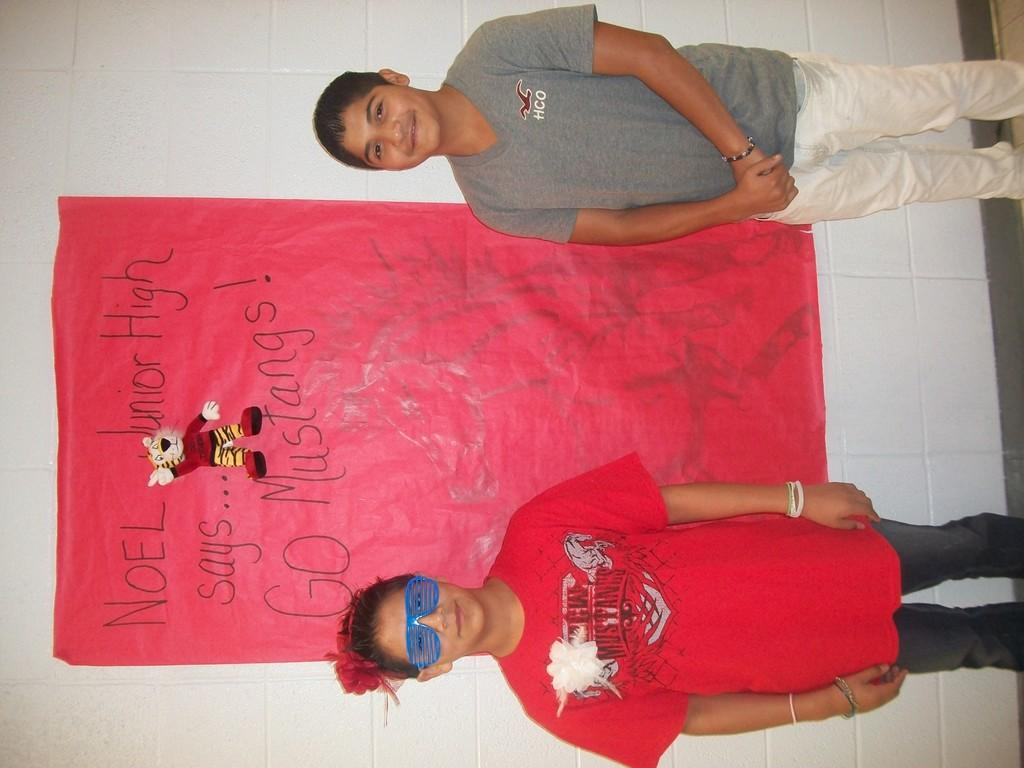How many children are present in the image? There are two children standing in the image. Where are the children standing? The children are standing on the floor. What can be seen on the wall in the background of the image? There is a paper on the wall, which has a picture and some text on it. What type of bean is being used as a prop in the image? There is no bean present in the image. What day of the week is depicted in the image? The image does not depict a specific day of the week. 